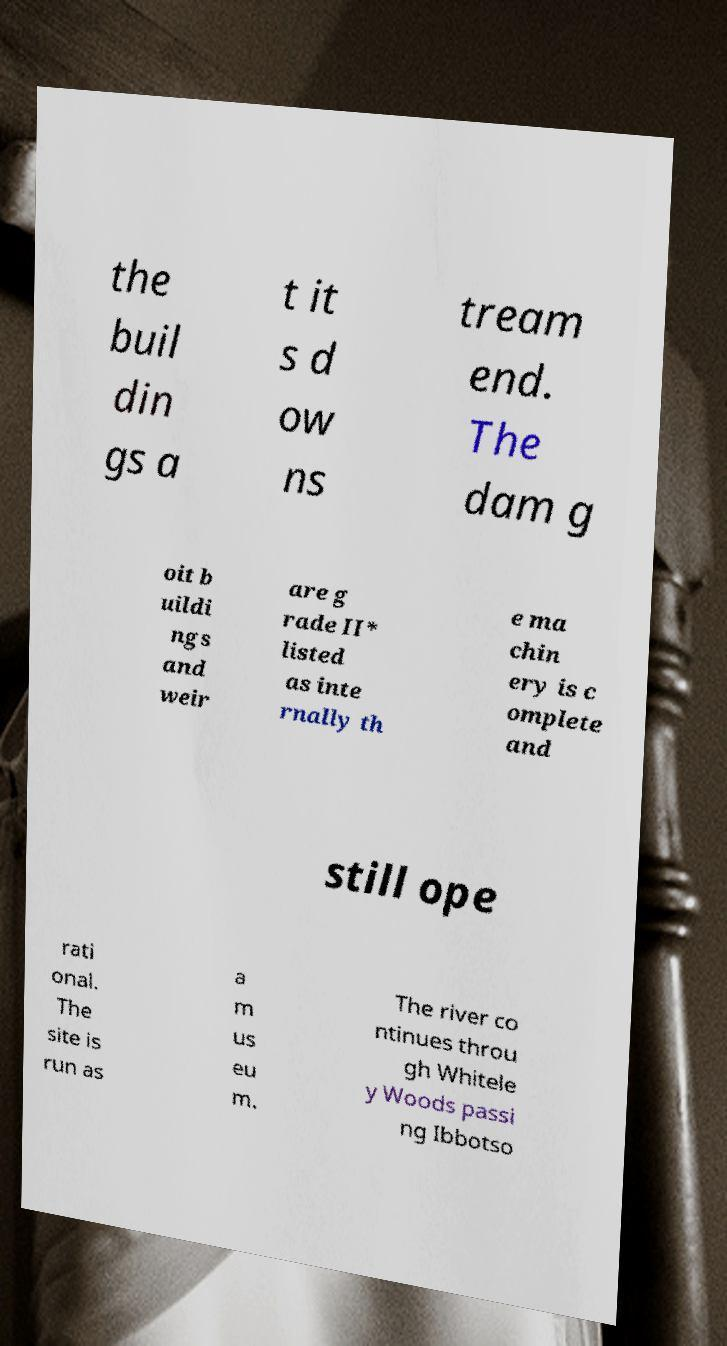What messages or text are displayed in this image? I need them in a readable, typed format. the buil din gs a t it s d ow ns tream end. The dam g oit b uildi ngs and weir are g rade II* listed as inte rnally th e ma chin ery is c omplete and still ope rati onal. The site is run as a m us eu m. The river co ntinues throu gh Whitele y Woods passi ng Ibbotso 